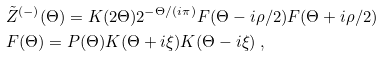Convert formula to latex. <formula><loc_0><loc_0><loc_500><loc_500>& \tilde { Z } ^ { ( - ) } ( \Theta ) = K ( 2 \Theta ) 2 ^ { - \Theta / ( i \pi ) } F ( \Theta - i \rho / 2 ) F ( \Theta + i \rho / 2 ) \\ & F ( \Theta ) = P ( \Theta ) K ( \Theta + i \xi ) K ( \Theta - i \xi ) \ ,</formula> 